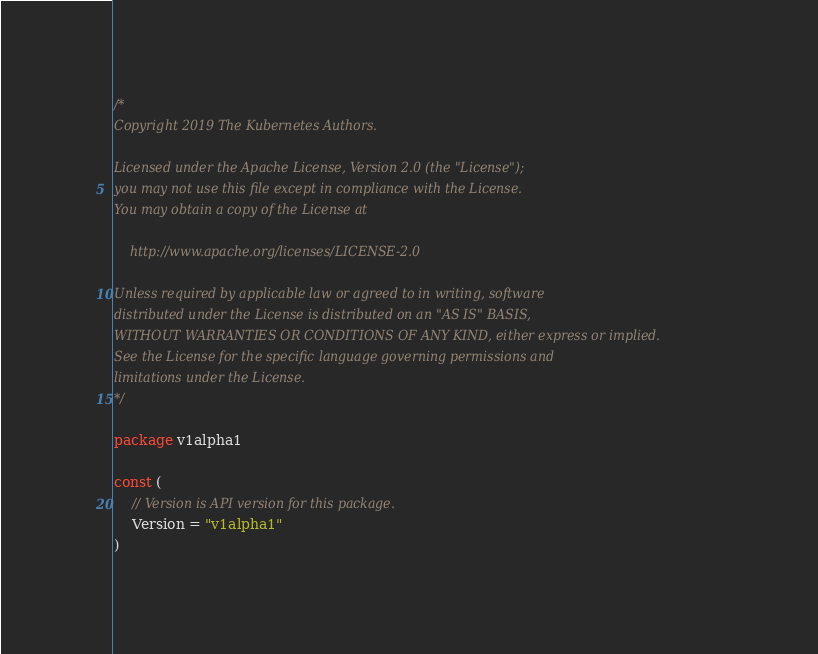Convert code to text. <code><loc_0><loc_0><loc_500><loc_500><_Go_>/*
Copyright 2019 The Kubernetes Authors.

Licensed under the Apache License, Version 2.0 (the "License");
you may not use this file except in compliance with the License.
You may obtain a copy of the License at

    http://www.apache.org/licenses/LICENSE-2.0

Unless required by applicable law or agreed to in writing, software
distributed under the License is distributed on an "AS IS" BASIS,
WITHOUT WARRANTIES OR CONDITIONS OF ANY KIND, either express or implied.
See the License for the specific language governing permissions and
limitations under the License.
*/

package v1alpha1

const (
	// Version is API version for this package.
	Version = "v1alpha1"
)
</code> 